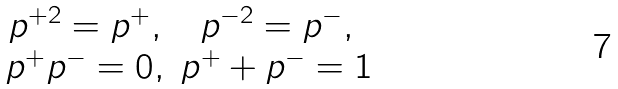<formula> <loc_0><loc_0><loc_500><loc_500>\begin{array} { c c } p ^ { + 2 } = p ^ { + } , & p ^ { - 2 } = p ^ { - } , \\ p ^ { + } p ^ { - } = 0 , & p ^ { + } + p ^ { - } = 1 \end{array}</formula> 